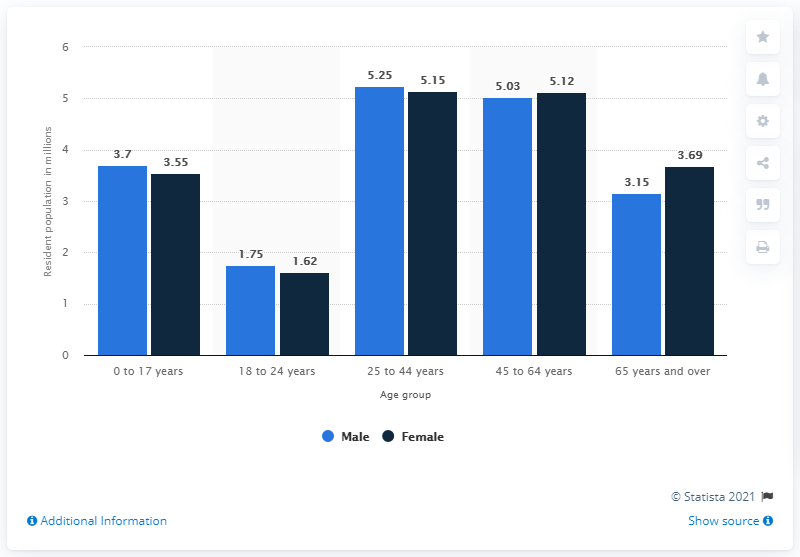Highlight a few significant elements in this photo. There were 5.15 females who lived between the ages of 45 and 64. In 2020, there were approximately 23.45 million females in Canada between the ages of 25 and 44. 